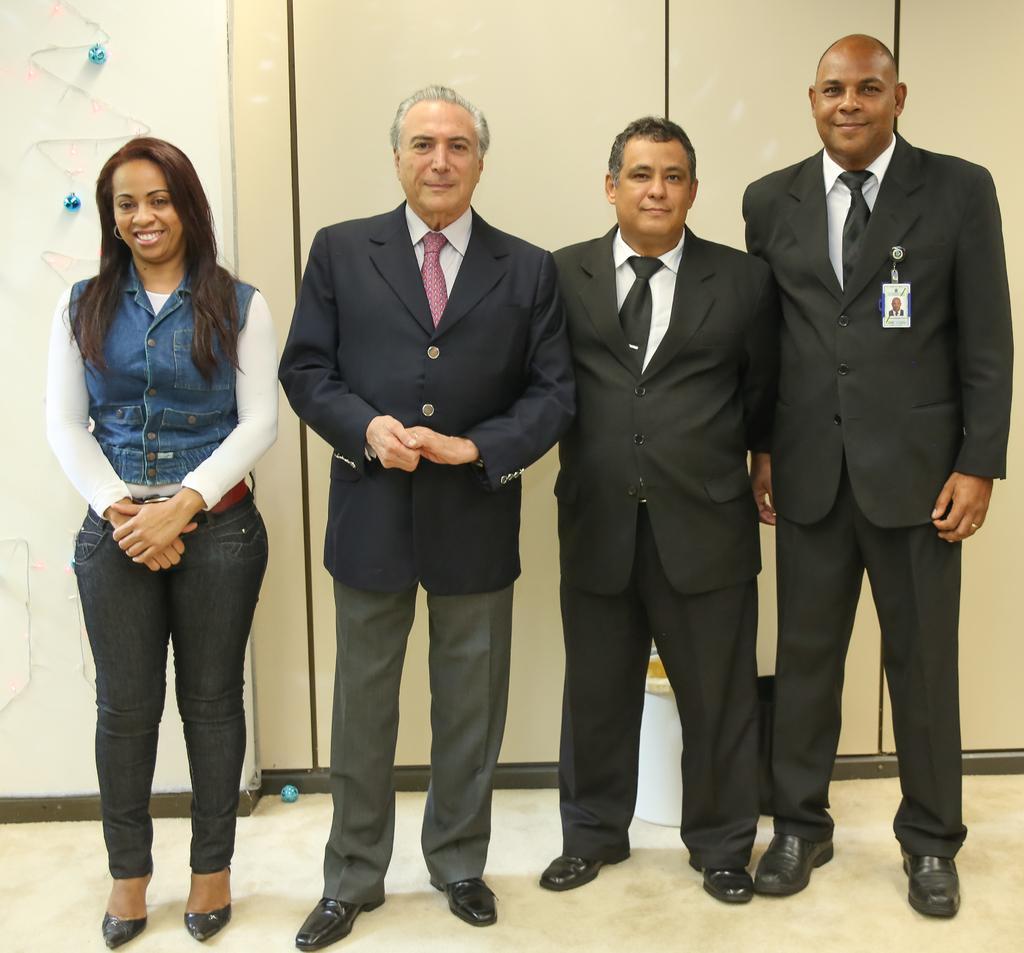How would you summarize this image in a sentence or two? In this image in the center there are some people who are standing, and in the background there is a wall and some objects. At the bottom there is a floor. 